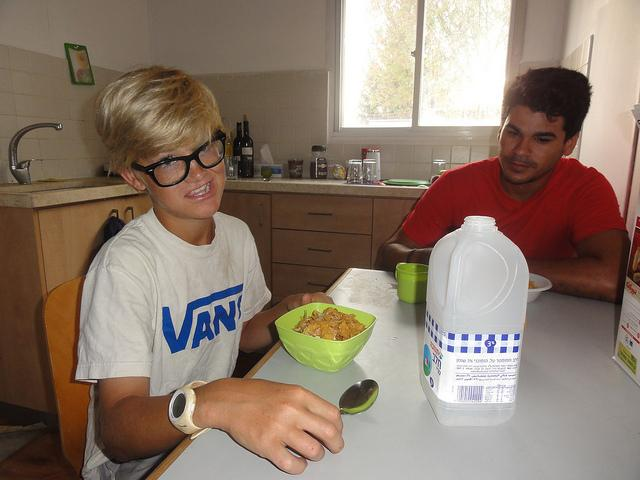What product does the young diner run out of here? milk 